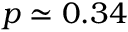Convert formula to latex. <formula><loc_0><loc_0><loc_500><loc_500>p \simeq 0 . 3 4</formula> 